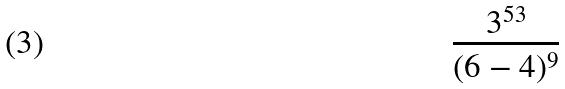<formula> <loc_0><loc_0><loc_500><loc_500>\frac { 3 ^ { 5 3 } } { ( 6 - 4 ) ^ { 9 } }</formula> 